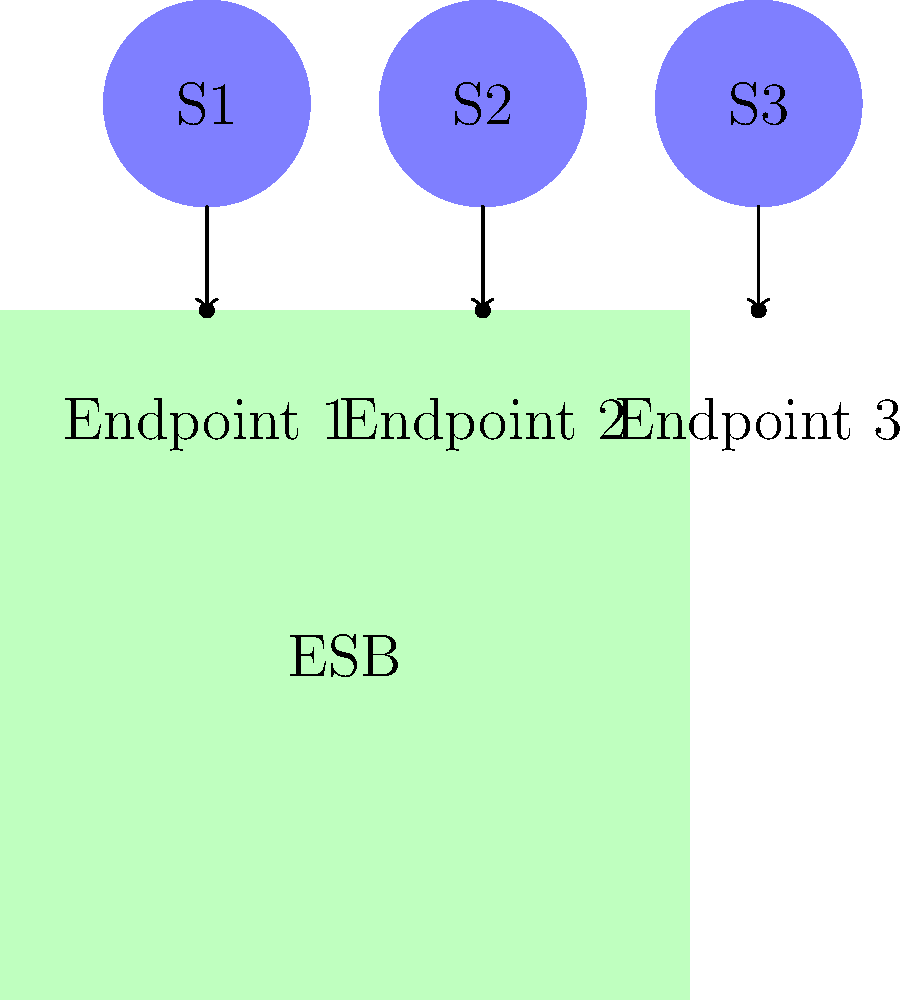In the given ESB architecture diagram, which component is responsible for mapping the service endpoints to the corresponding services? To answer this question, let's break down the components of the ESB architecture diagram:

1. The large green box in the center represents the Enterprise Service Bus (ESB).
2. The blue circles at the top represent different services (S1, S2, S3).
3. The dots on the ESB represent the endpoints.
4. The arrows connecting the services to the endpoints indicate the mapping between services and endpoints.

In an ESB architecture:

1. The ESB acts as a central middleware component that facilitates communication between different services.
2. One of the key responsibilities of the ESB is to manage service endpoints.
3. The ESB handles the mapping between service endpoints and the actual services.
4. This mapping allows the ESB to route requests to the appropriate service based on the endpoint that receives the request.
5. By managing these mappings, the ESB provides a level of abstraction between the service consumers and the service providers.

Therefore, the component responsible for mapping the service endpoints to the corresponding services is the Enterprise Service Bus (ESB) itself.
Answer: Enterprise Service Bus (ESB) 